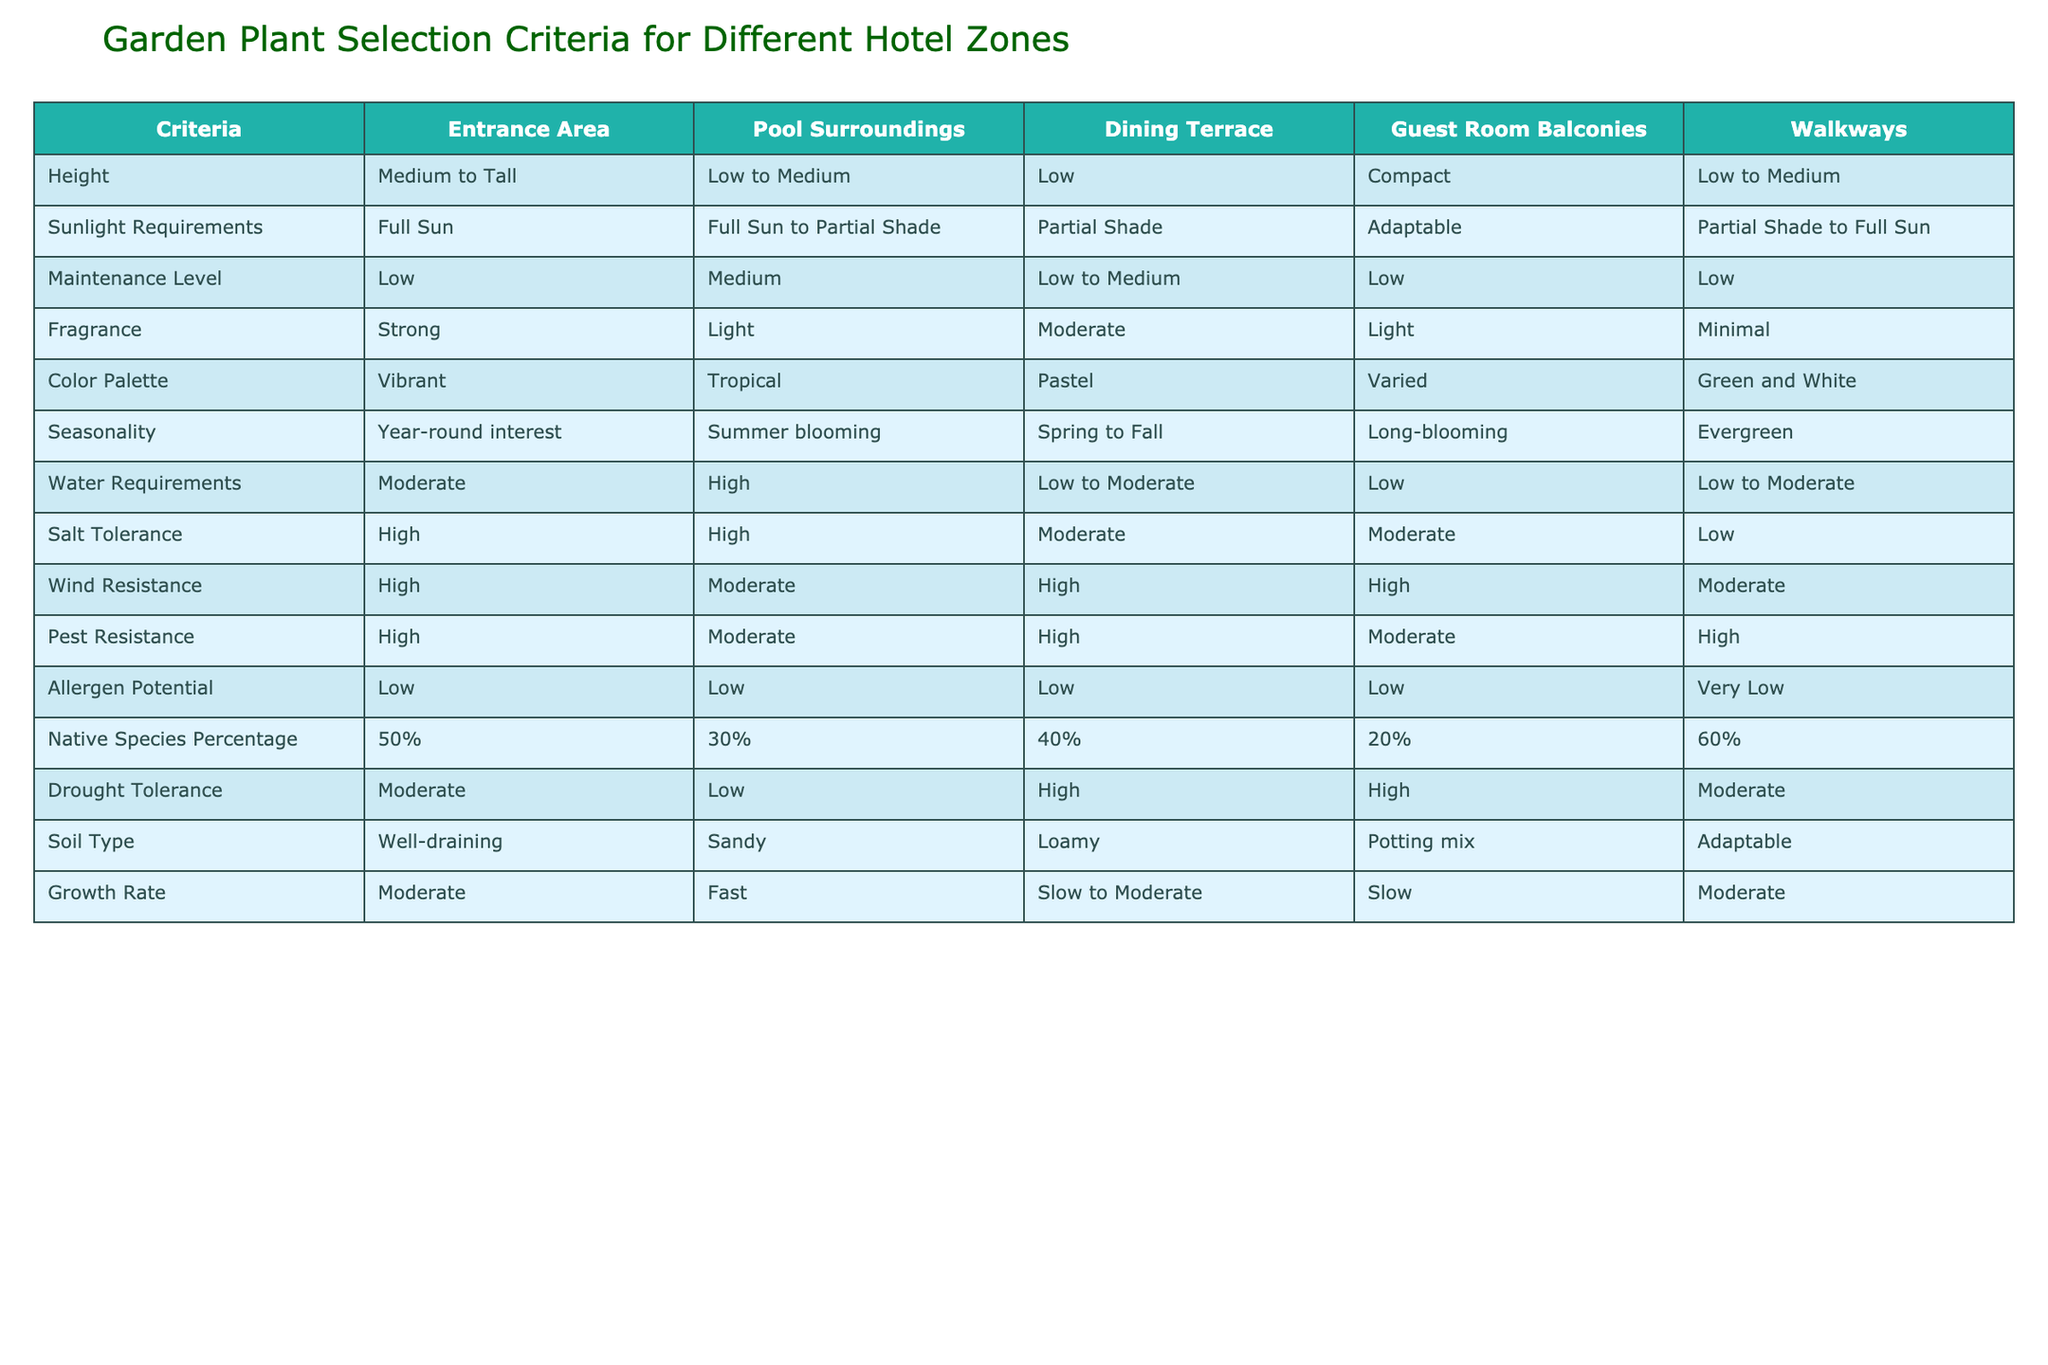What is the height requirement for plants in the Entrance Area? The table specifies the height requirement for the Entrance Area as "Medium to Tall," which is directly stated in the corresponding cell of the Height row.
Answer: Medium to Tall Which area requires plants with the highest water requirements? Looking at the Water Requirements row, the Pool Surroundings area has the highest requirement marked as "High."
Answer: Pool Surroundings Is the Guest Room Balconies area suitable for plants that require full sun? The table shows that the sunlight requirement for Guest Room Balconies is "Adaptable," meaning the area could potentially accommodate plants that thrive in full sun, but it is not explicitly required.
Answer: No What percentage of native species is represented in the Walkways area? The Walkways area has a native species percentage of 60%, as indicated in the Native Species Percentage row.
Answer: 60% What is the average height requirement for plants in the Pool Surroundings and Dining Terrace areas? The height requirements for Pool Surroundings and Dining Terrace are "Low to Medium" and "Low," respectively. Since "Low" can be seen as low (1), and "Medium" can be perceived as halfway (2), the average height falls between 1 and 2, which is 1.5. Thus the average height can be described as "Low to Medium."
Answer: Low to Medium Which garden area has the least fragrant plants on average? By assessing the Fragrance row, the Walkways area has "Minimal" fragrance according to the table, indicating it features the least fragrant plants compared to the other areas.
Answer: Walkways Are all the areas resistant to pests? By examining the Pest Resistance row, all areas listed have a pest resistance level, but only the Guest Room Balconies area is marked as "Moderate," while others are "High." This indicates all areas are resistant, but at differing levels.
Answer: Yes What area has both high salt tolerance and wind resistance? Both the Entrance Area and Pool Surroundings show "High" in both Salt Tolerance and Wind Resistance rows, indicating they both meet the criteria.
Answer: Entrance Area, Pool Surroundings Which zone is best for plants that bloom primarily in summer? The table indicates that the Pool Surroundings area is designated as "Summer blooming" in the Seasonality row, making it the most suitable zone for such plants.
Answer: Pool Surroundings 